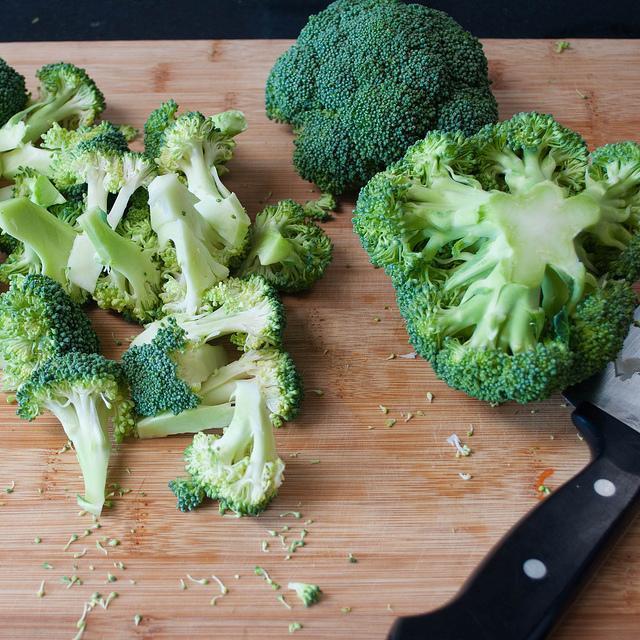How many rivets are on the handle?
Give a very brief answer. 2. How many broccolis are there?
Give a very brief answer. 2. How many people are holding a camera?
Give a very brief answer. 0. 